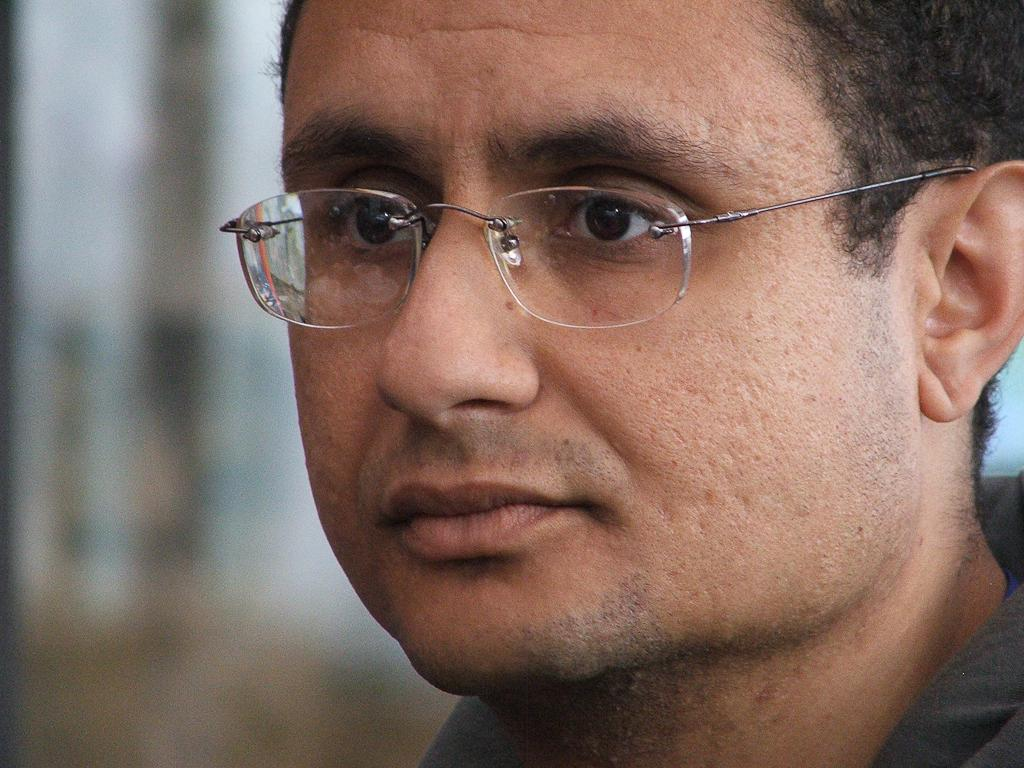What is the main subject of the image? There is a man in the image. What accessory is the man wearing? The man is wearing glasses. Can you describe the background of the image? The background of the image is blurred. How much payment does the man receive in the image? There is no indication of payment in the image; it only shows a man wearing glasses with a blurred background. 